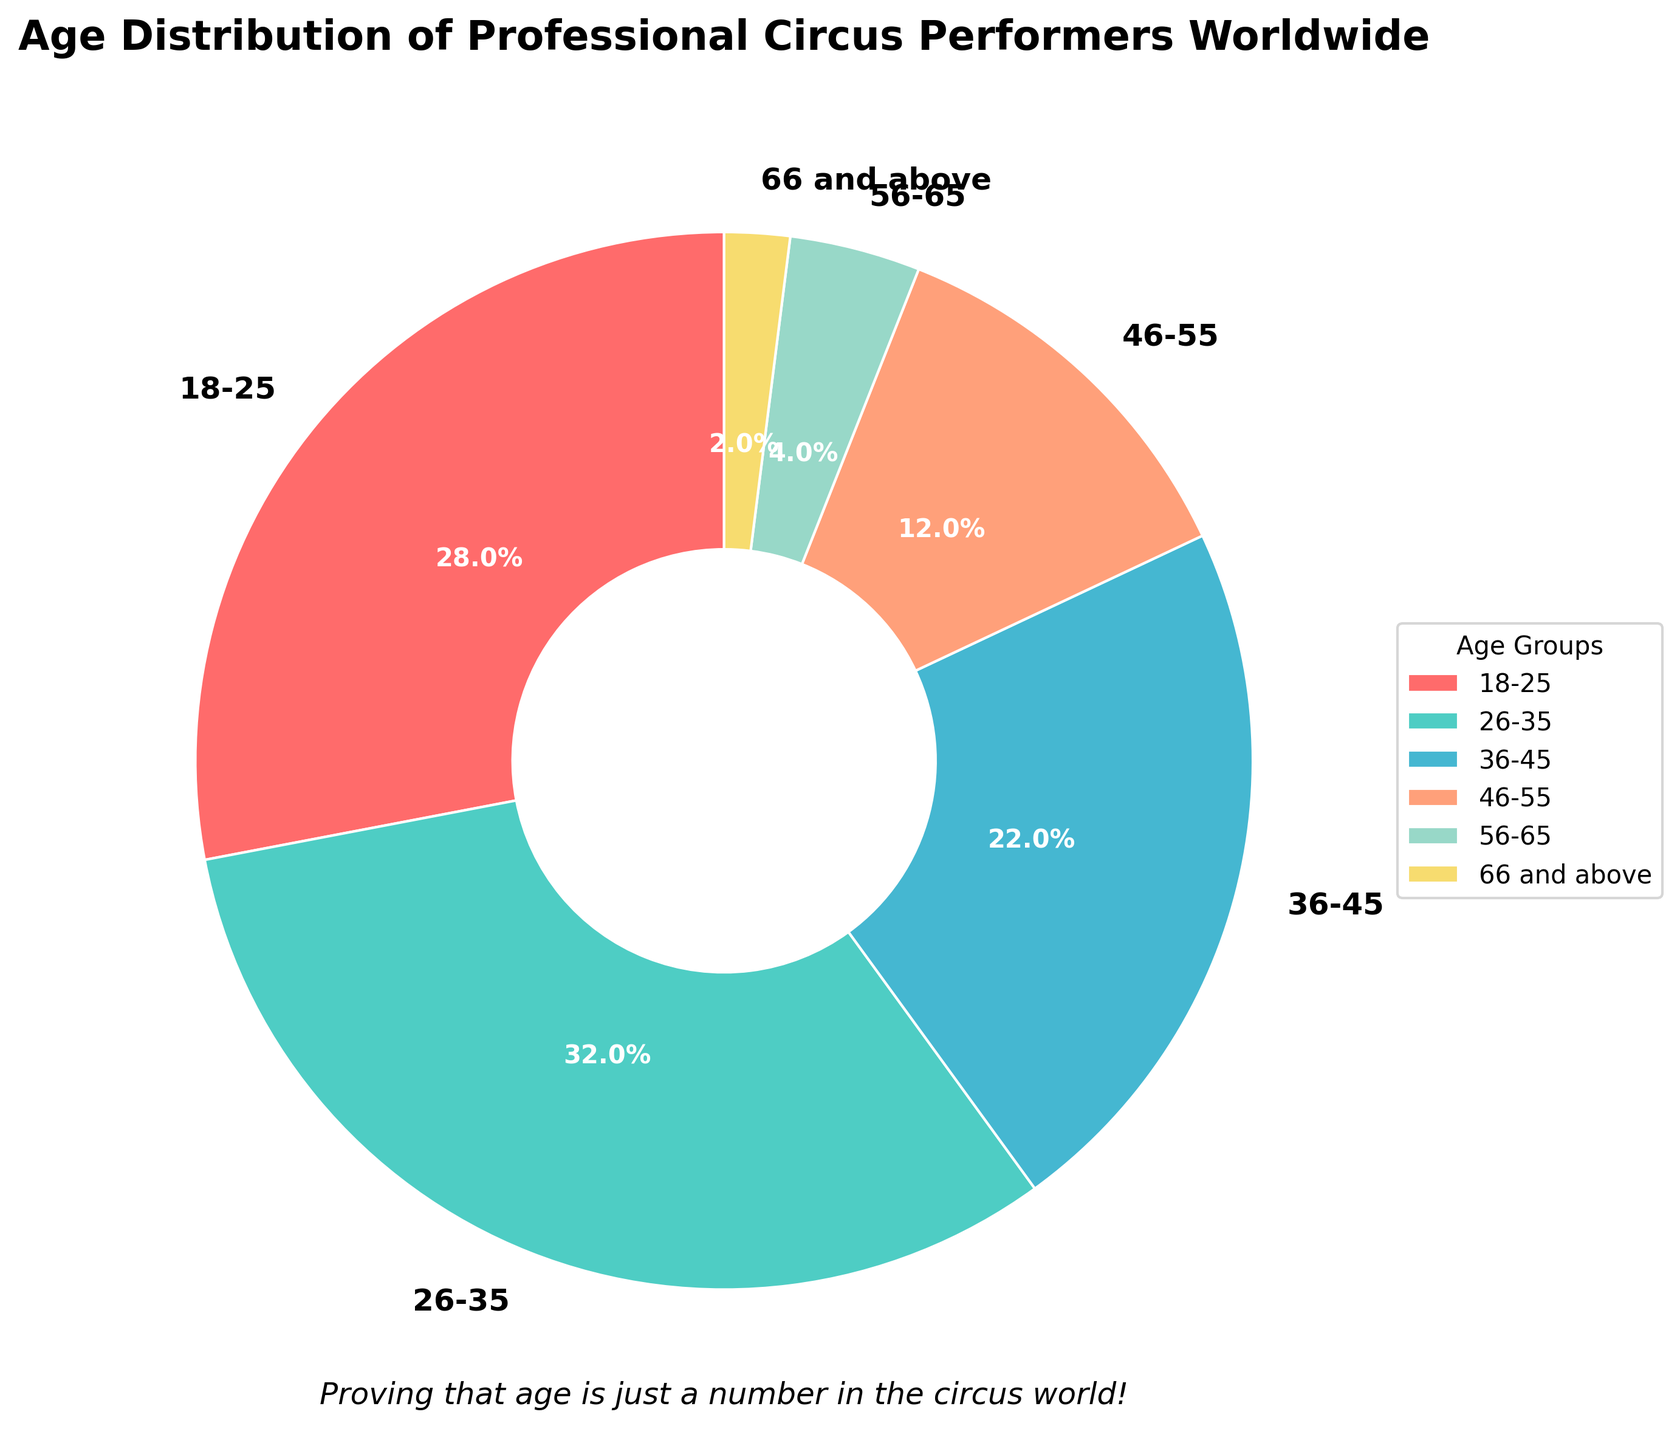what percentage of circus performers are aged 26-35? Observing the pie chart, the segment labeled "26-35" has an autopct of 32.0%
Answer: 32% which age group has the least percentage of circus performers? By looking at the pie chart, the segment for the age group "66 and above" is the smallest and labeled with 2%
Answer: 66 and above What is the combined percentage of performers over 45 years old? To find this, sum the percentages of the "46-55", "56-65", and "66 and above" groups: 12% + 4% + 2% = 18%
Answer: 18% Which two age groups together form the largest percentage of performers? The two age groups with the highest percentages are "18-25" (28%) and "26-35" (32%). Combined, they form 28% + 32% = 60%
Answer: 18-25 and 26-35 Is the percentage of performers aged 36-45 greater than the combined percentage of those aged 56 and above? The percentage for "36-45" is 22%. The combined percentage of "56-65" (4%) and "66 and above" (2%) is 4% + 2% = 6%. Since 22% is greater than 6%, the answer is yes
Answer: Yes What is the difference in percentage between the 18-25 and 36-45 age groups? Subtract the percentage of the "36-45" age group from the "18-25" age group: 28% - 22% = 6%
Answer: 6% Which segment in the pie chart is colored blue? The second largest segment in the pie chart (32%) which corresponds to the "26-35" age group is colored in a blue shade
Answer: 26-35 How many age groups have a percentage greater than 20%? By examining the pie chart, the age groups "18-25" (28%), "26-35" (32%), and "36-45" (22%) each have percentages greater than 20%. Therefore, there are 3
Answer: 3 